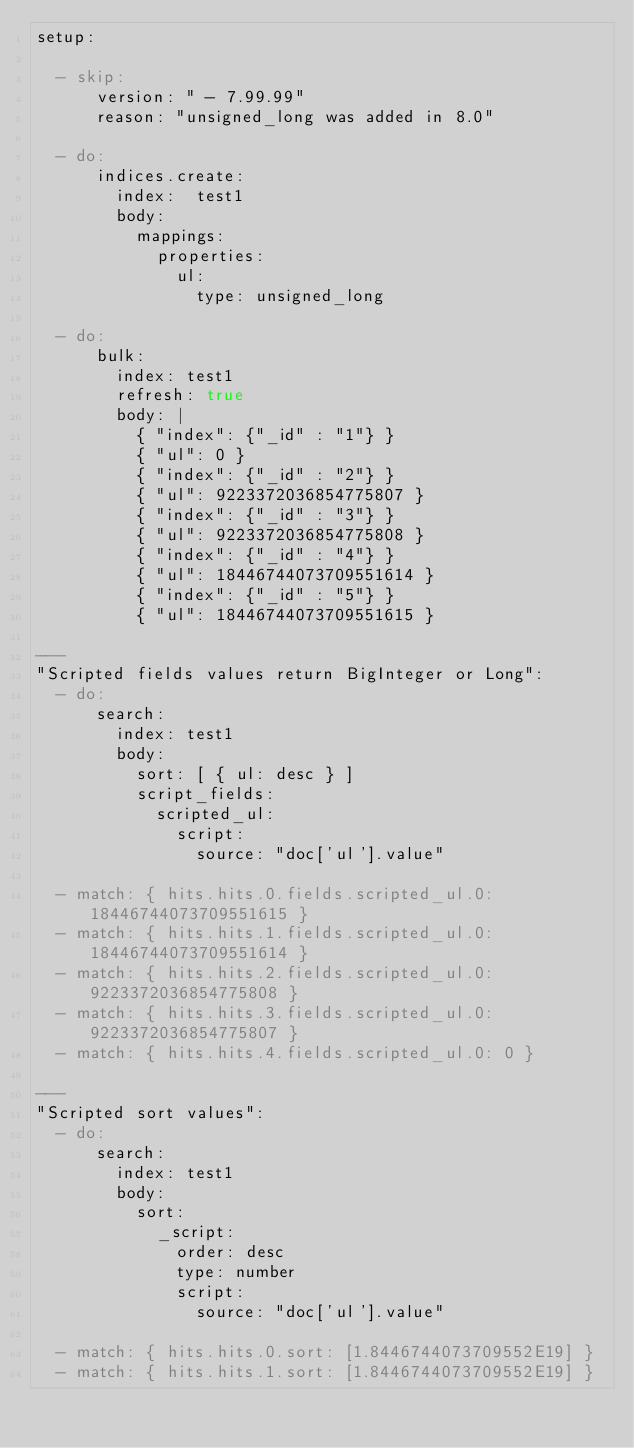<code> <loc_0><loc_0><loc_500><loc_500><_YAML_>setup:

  - skip:
      version: " - 7.99.99"
      reason: "unsigned_long was added in 8.0"

  - do:
      indices.create:
        index:  test1
        body:
          mappings:
            properties:
              ul:
                type: unsigned_long

  - do:
      bulk:
        index: test1
        refresh: true
        body: |
          { "index": {"_id" : "1"} }
          { "ul": 0 }
          { "index": {"_id" : "2"} }
          { "ul": 9223372036854775807 }
          { "index": {"_id" : "3"} }
          { "ul": 9223372036854775808 }
          { "index": {"_id" : "4"} }
          { "ul": 18446744073709551614 }
          { "index": {"_id" : "5"} }
          { "ul": 18446744073709551615 }

---
"Scripted fields values return BigInteger or Long":
  - do:
      search:
        index: test1
        body:
          sort: [ { ul: desc } ]
          script_fields:
            scripted_ul:
              script:
                source: "doc['ul'].value"

  - match: { hits.hits.0.fields.scripted_ul.0: 18446744073709551615 }
  - match: { hits.hits.1.fields.scripted_ul.0: 18446744073709551614 }
  - match: { hits.hits.2.fields.scripted_ul.0: 9223372036854775808 }
  - match: { hits.hits.3.fields.scripted_ul.0: 9223372036854775807 }
  - match: { hits.hits.4.fields.scripted_ul.0: 0 }

---
"Scripted sort values":
  - do:
      search:
        index: test1
        body:
          sort:
            _script:
              order: desc
              type: number
              script:
                source: "doc['ul'].value"

  - match: { hits.hits.0.sort: [1.8446744073709552E19] }
  - match: { hits.hits.1.sort: [1.8446744073709552E19] }</code> 